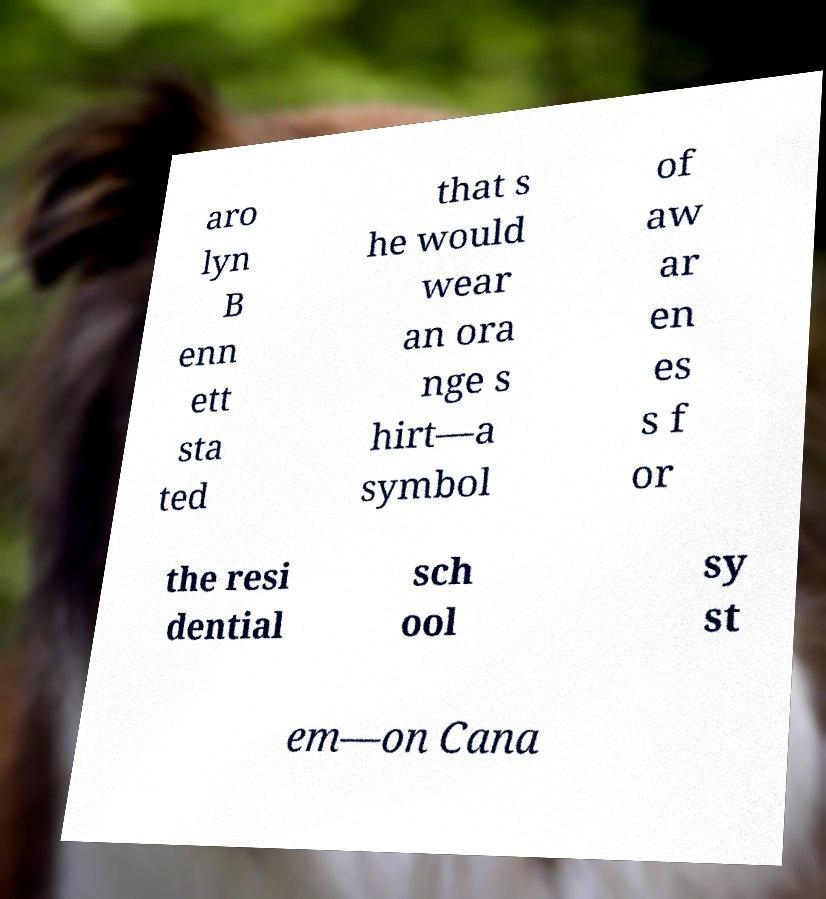Please identify and transcribe the text found in this image. aro lyn B enn ett sta ted that s he would wear an ora nge s hirt—a symbol of aw ar en es s f or the resi dential sch ool sy st em—on Cana 